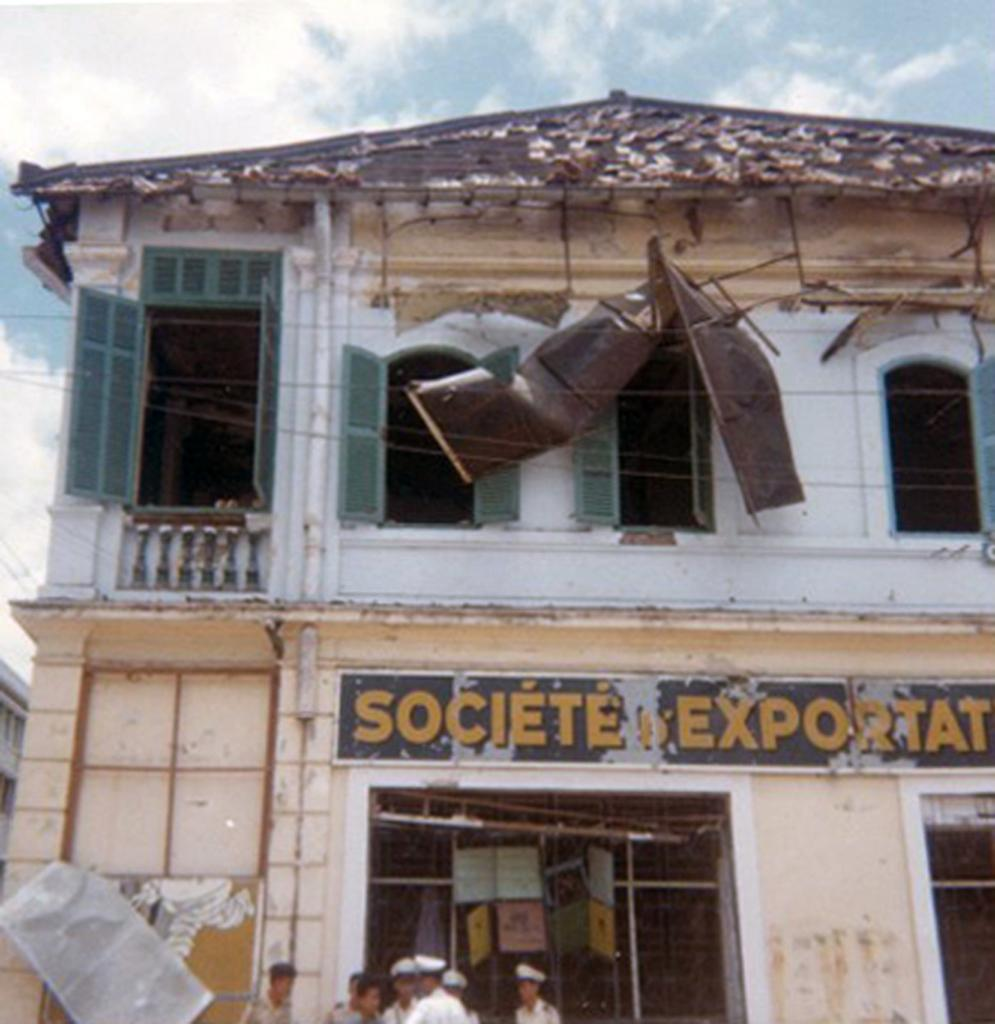What is happening on the road in the image? There is a group of people on the road in the image. What can be seen in the background of the image? There is a building in the image, and the sky is blue in the background. Can you tell if the image was taken during the day or night? The image is likely taken during the day, as the sky is blue and there is no indication of darkness. How much salt is being used by the people in the image? There is no salt present in the image, as it features a group of people on the road and a building in the background. What type of lamp is being used by the people in the image? There is no lamp present in the image, as it features a group of people on the people on the road and a building in the background. 